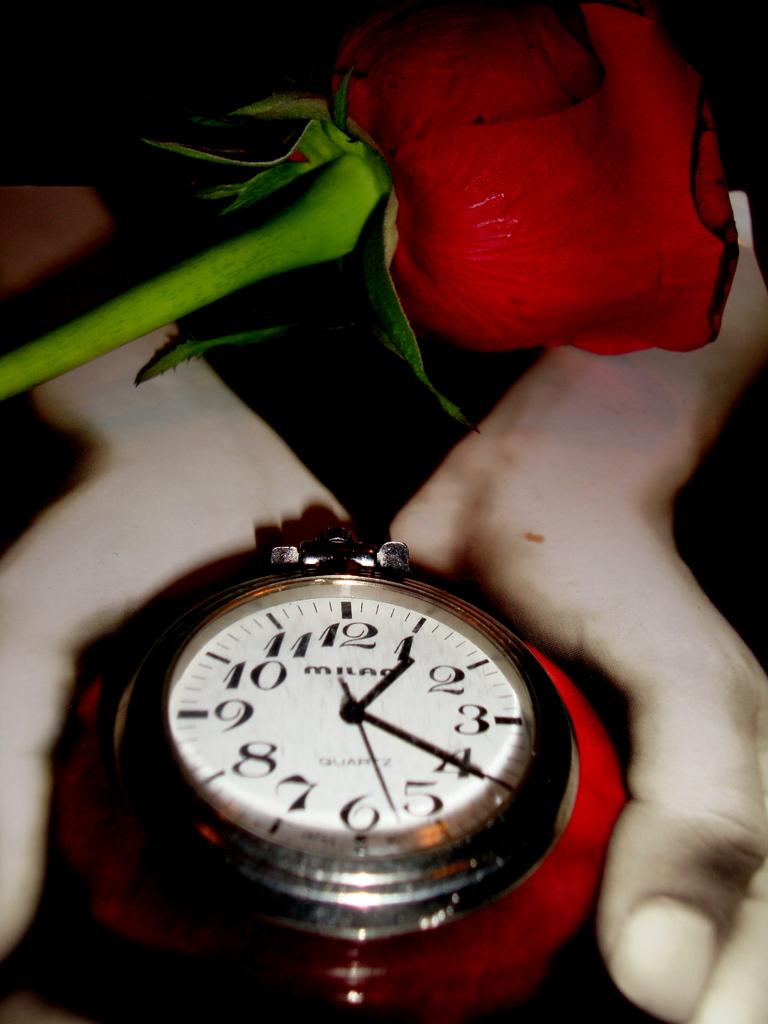What time is on the watch?
Offer a very short reply. 1:20. 